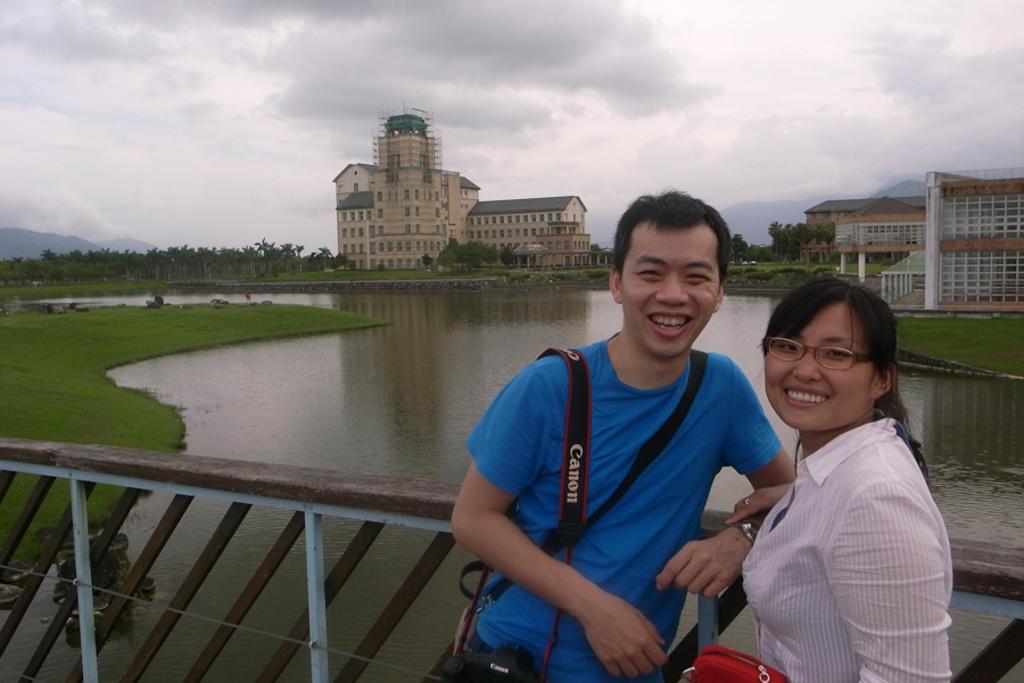Is the brand on the strap the same as the camera bag?
Ensure brevity in your answer.  Yes. 